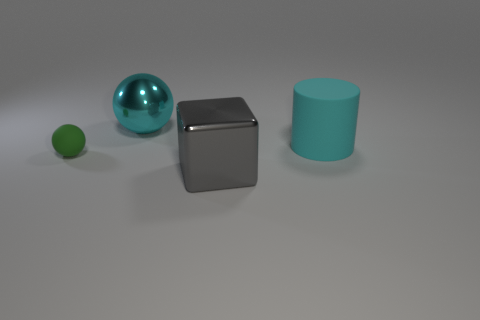Add 3 yellow spheres. How many objects exist? 7 Subtract all cylinders. How many objects are left? 3 Add 2 cyan metal things. How many cyan metal things are left? 3 Add 1 big cyan cylinders. How many big cyan cylinders exist? 2 Subtract 0 yellow cubes. How many objects are left? 4 Subtract all matte objects. Subtract all big cylinders. How many objects are left? 1 